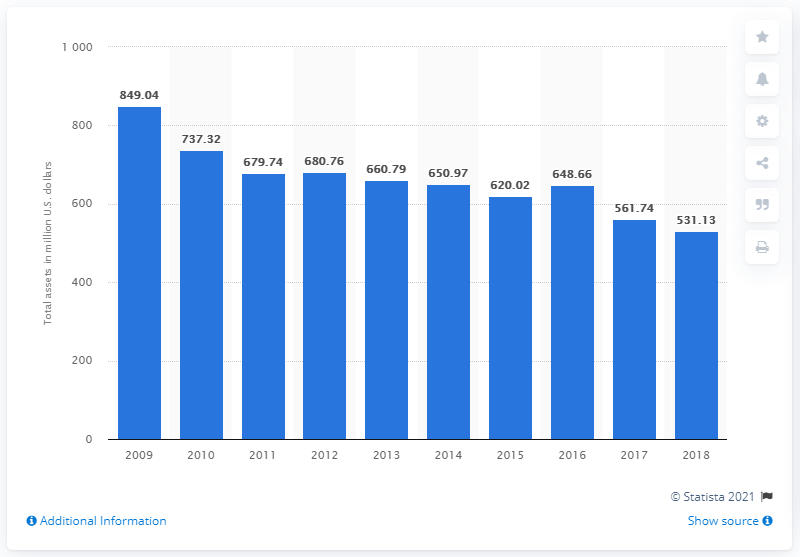Highlight a few significant elements in this photo. Sonic Corp.'s total assets in 2018 were 531.13 million. 